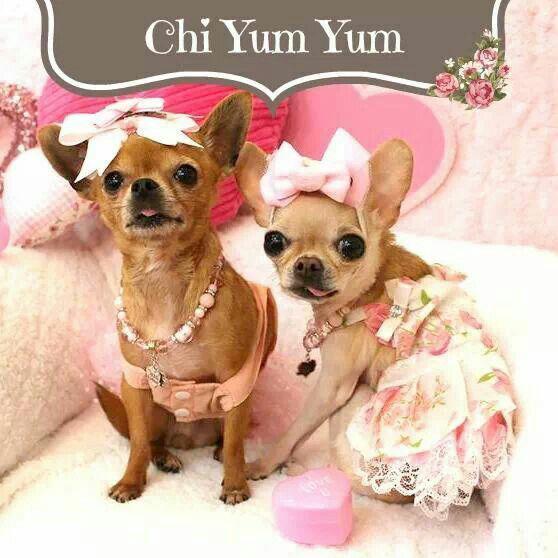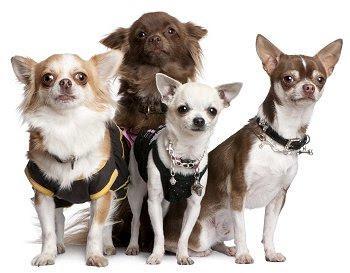The first image is the image on the left, the second image is the image on the right. Assess this claim about the two images: "An image shows exactly two dogs wearing fancy garb.". Correct or not? Answer yes or no. Yes. The first image is the image on the left, the second image is the image on the right. Analyze the images presented: Is the assertion "An equal number of puppies are in each image." valid? Answer yes or no. No. The first image is the image on the left, the second image is the image on the right. Examine the images to the left and right. Is the description "One of the images shows exactly two dogs." accurate? Answer yes or no. Yes. 